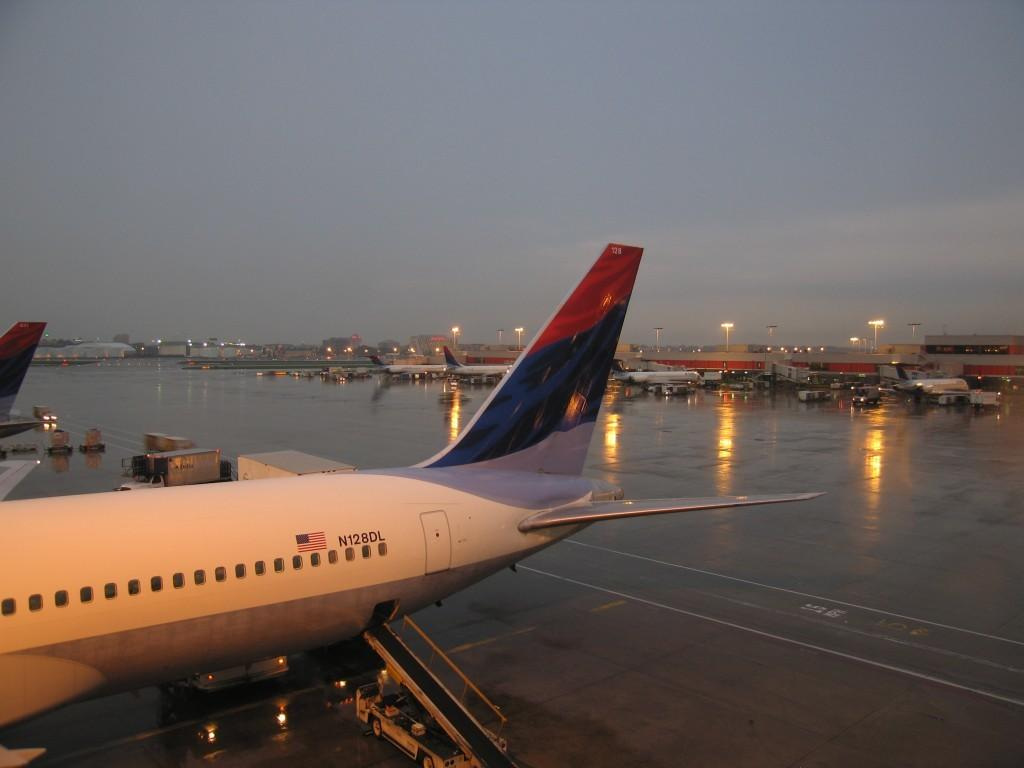Where was the image taken? The image was taken at an airport. What can be seen in the image besides the airport setting? There are airplanes in the image. What is visible in the background of the image? There is a sky visible in the background of the image. What type of tools does the carpenter have in the image? There is no carpenter present in the image, so no tools can be observed. 